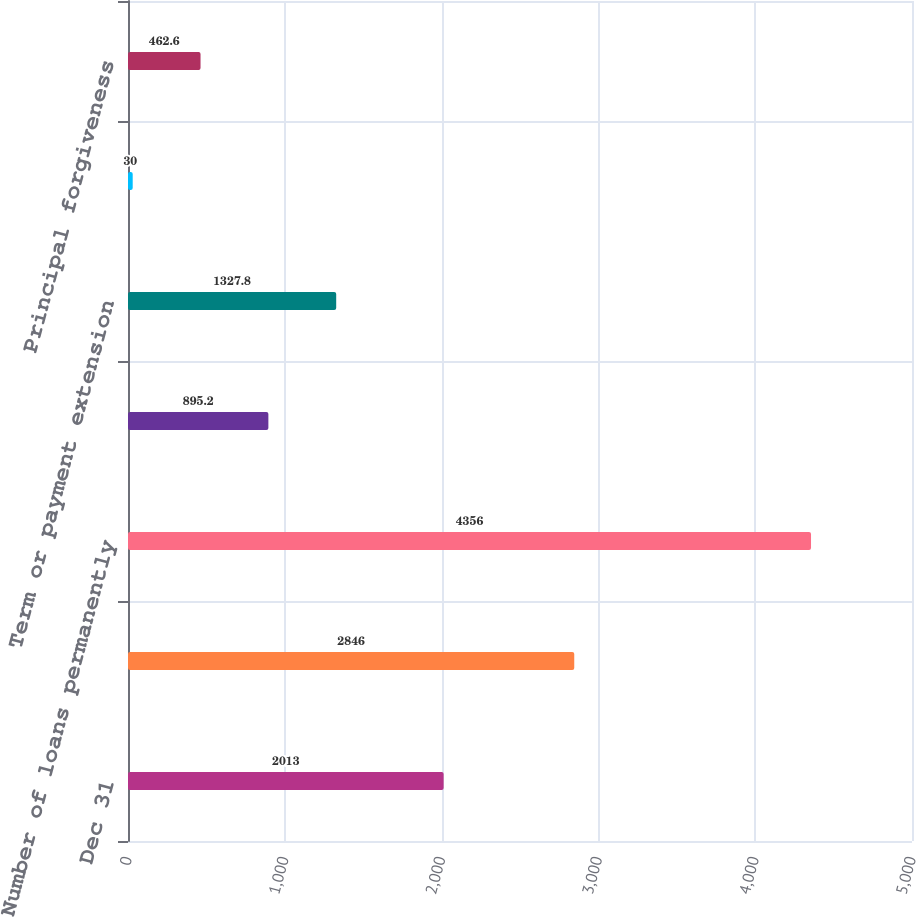Convert chart. <chart><loc_0><loc_0><loc_500><loc_500><bar_chart><fcel>Dec 31<fcel>Number of loans approved for a<fcel>Number of loans permanently<fcel>Interest rate reduction<fcel>Term or payment extension<fcel>Principal and/or interest<fcel>Principal forgiveness<nl><fcel>2013<fcel>2846<fcel>4356<fcel>895.2<fcel>1327.8<fcel>30<fcel>462.6<nl></chart> 